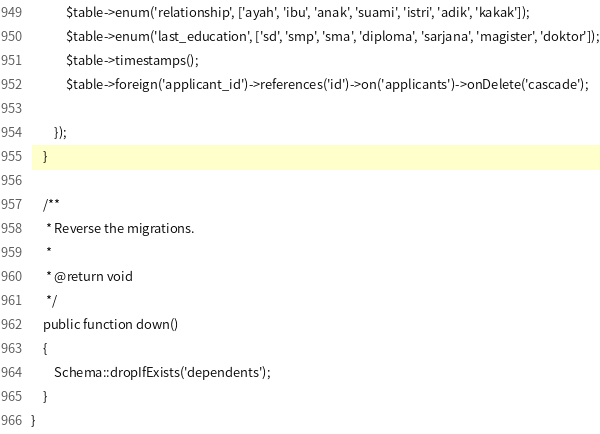<code> <loc_0><loc_0><loc_500><loc_500><_PHP_>            $table->enum('relationship', ['ayah', 'ibu', 'anak', 'suami', 'istri', 'adik', 'kakak']);
            $table->enum('last_education', ['sd', 'smp', 'sma', 'diploma', 'sarjana', 'magister', 'doktor']);
            $table->timestamps();
            $table->foreign('applicant_id')->references('id')->on('applicants')->onDelete('cascade');

        });
    }

    /**
     * Reverse the migrations.
     *
     * @return void
     */
    public function down()
    {
        Schema::dropIfExists('dependents');
    }
}
</code> 